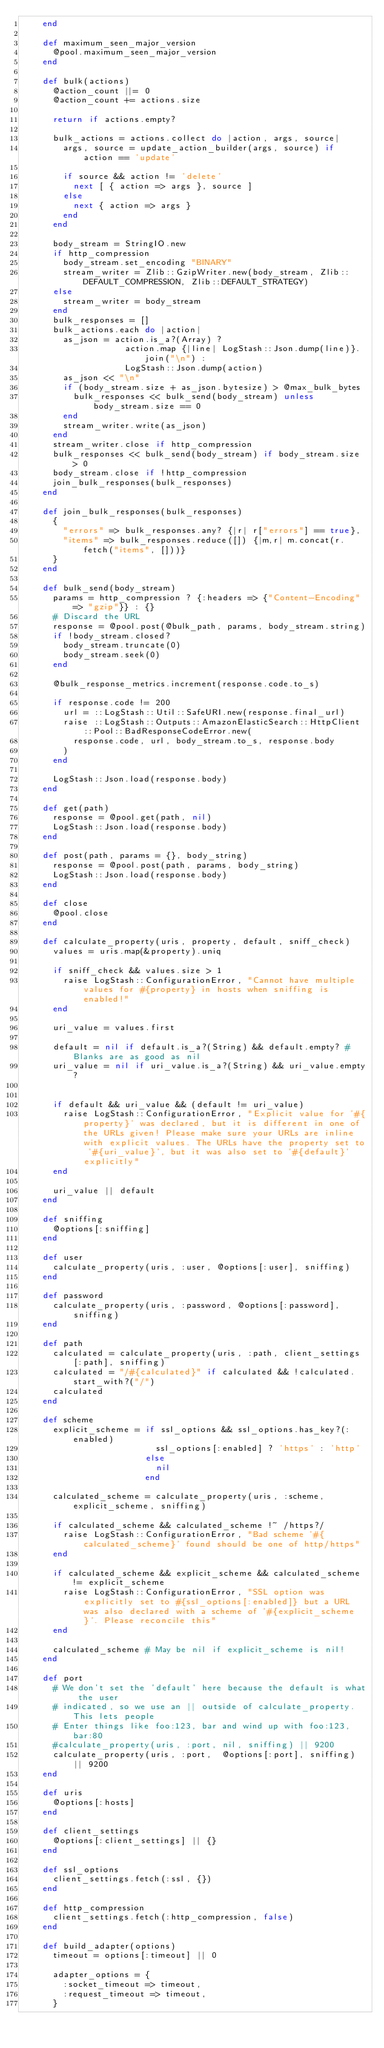<code> <loc_0><loc_0><loc_500><loc_500><_Ruby_>    end

    def maximum_seen_major_version
      @pool.maximum_seen_major_version
    end

    def bulk(actions)
      @action_count ||= 0
      @action_count += actions.size

      return if actions.empty?

      bulk_actions = actions.collect do |action, args, source|
        args, source = update_action_builder(args, source) if action == 'update'

        if source && action != 'delete'
          next [ { action => args }, source ]
        else
          next { action => args }
        end
      end

      body_stream = StringIO.new
      if http_compression
        body_stream.set_encoding "BINARY"
        stream_writer = Zlib::GzipWriter.new(body_stream, Zlib::DEFAULT_COMPRESSION, Zlib::DEFAULT_STRATEGY)
      else 
        stream_writer = body_stream
      end
      bulk_responses = []
      bulk_actions.each do |action|
        as_json = action.is_a?(Array) ?
                    action.map {|line| LogStash::Json.dump(line)}.join("\n") :
                    LogStash::Json.dump(action)
        as_json << "\n"
        if (body_stream.size + as_json.bytesize) > @max_bulk_bytes
          bulk_responses << bulk_send(body_stream) unless body_stream.size == 0
        end
        stream_writer.write(as_json)
      end
      stream_writer.close if http_compression
      bulk_responses << bulk_send(body_stream) if body_stream.size > 0
      body_stream.close if !http_compression
      join_bulk_responses(bulk_responses)
    end

    def join_bulk_responses(bulk_responses)
      {
        "errors" => bulk_responses.any? {|r| r["errors"] == true},
        "items" => bulk_responses.reduce([]) {|m,r| m.concat(r.fetch("items", []))}
      }
    end

    def bulk_send(body_stream)
      params = http_compression ? {:headers => {"Content-Encoding" => "gzip"}} : {}
      # Discard the URL
      response = @pool.post(@bulk_path, params, body_stream.string)
      if !body_stream.closed?
        body_stream.truncate(0)
        body_stream.seek(0)
      end

      @bulk_response_metrics.increment(response.code.to_s)

      if response.code != 200
        url = ::LogStash::Util::SafeURI.new(response.final_url)
        raise ::LogStash::Outputs::AmazonElasticSearch::HttpClient::Pool::BadResponseCodeError.new(
          response.code, url, body_stream.to_s, response.body
        )
      end

      LogStash::Json.load(response.body)
    end

    def get(path)
      response = @pool.get(path, nil)
      LogStash::Json.load(response.body)
    end

    def post(path, params = {}, body_string)
      response = @pool.post(path, params, body_string)
      LogStash::Json.load(response.body)
    end

    def close
      @pool.close
    end

    def calculate_property(uris, property, default, sniff_check)
      values = uris.map(&property).uniq

      if sniff_check && values.size > 1
        raise LogStash::ConfigurationError, "Cannot have multiple values for #{property} in hosts when sniffing is enabled!"
      end

      uri_value = values.first

      default = nil if default.is_a?(String) && default.empty? # Blanks are as good as nil
      uri_value = nil if uri_value.is_a?(String) && uri_value.empty?


      if default && uri_value && (default != uri_value)
        raise LogStash::ConfigurationError, "Explicit value for '#{property}' was declared, but it is different in one of the URLs given! Please make sure your URLs are inline with explicit values. The URLs have the property set to '#{uri_value}', but it was also set to '#{default}' explicitly"
      end

      uri_value || default
    end

    def sniffing
      @options[:sniffing]
    end

    def user
      calculate_property(uris, :user, @options[:user], sniffing)
    end

    def password
      calculate_property(uris, :password, @options[:password], sniffing)
    end

    def path
      calculated = calculate_property(uris, :path, client_settings[:path], sniffing)
      calculated = "/#{calculated}" if calculated && !calculated.start_with?("/")
      calculated
    end

    def scheme
      explicit_scheme = if ssl_options && ssl_options.has_key?(:enabled)
                          ssl_options[:enabled] ? 'https' : 'http'
                        else
                          nil
                        end
      
      calculated_scheme = calculate_property(uris, :scheme, explicit_scheme, sniffing)

      if calculated_scheme && calculated_scheme !~ /https?/
        raise LogStash::ConfigurationError, "Bad scheme '#{calculated_scheme}' found should be one of http/https"
      end

      if calculated_scheme && explicit_scheme && calculated_scheme != explicit_scheme
        raise LogStash::ConfigurationError, "SSL option was explicitly set to #{ssl_options[:enabled]} but a URL was also declared with a scheme of '#{explicit_scheme}'. Please reconcile this"
      end

      calculated_scheme # May be nil if explicit_scheme is nil!
    end

    def port
      # We don't set the 'default' here because the default is what the user
      # indicated, so we use an || outside of calculate_property. This lets people
      # Enter things like foo:123, bar and wind up with foo:123, bar:80
      #calculate_property(uris, :port, nil, sniffing) || 9200
      calculate_property(uris, :port,  @options[:port], sniffing) || 9200
    end
    
    def uris
      @options[:hosts]
    end

    def client_settings
      @options[:client_settings] || {}
    end

    def ssl_options
      client_settings.fetch(:ssl, {})
    end

    def http_compression
      client_settings.fetch(:http_compression, false)
    end

    def build_adapter(options)
      timeout = options[:timeout] || 0
      
      adapter_options = {
        :socket_timeout => timeout,
        :request_timeout => timeout,
      }
</code> 